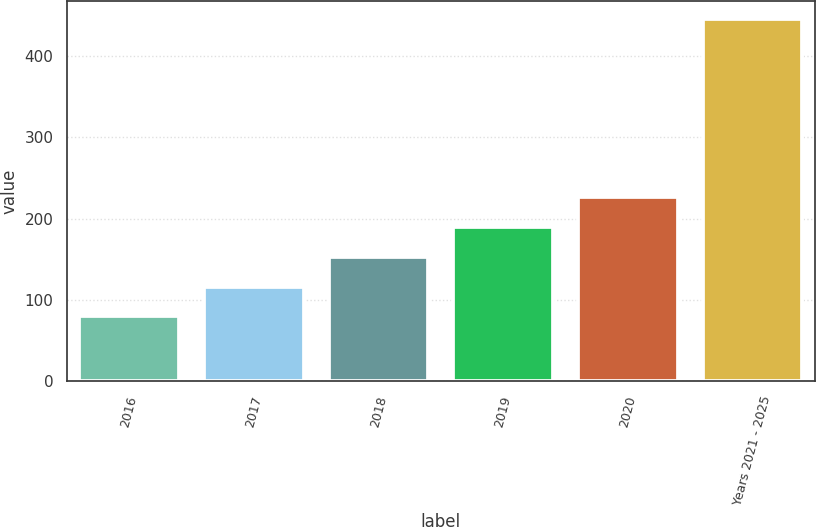Convert chart. <chart><loc_0><loc_0><loc_500><loc_500><bar_chart><fcel>2016<fcel>2017<fcel>2018<fcel>2019<fcel>2020<fcel>Years 2021 - 2025<nl><fcel>80<fcel>116.5<fcel>153<fcel>189.5<fcel>226<fcel>445<nl></chart> 